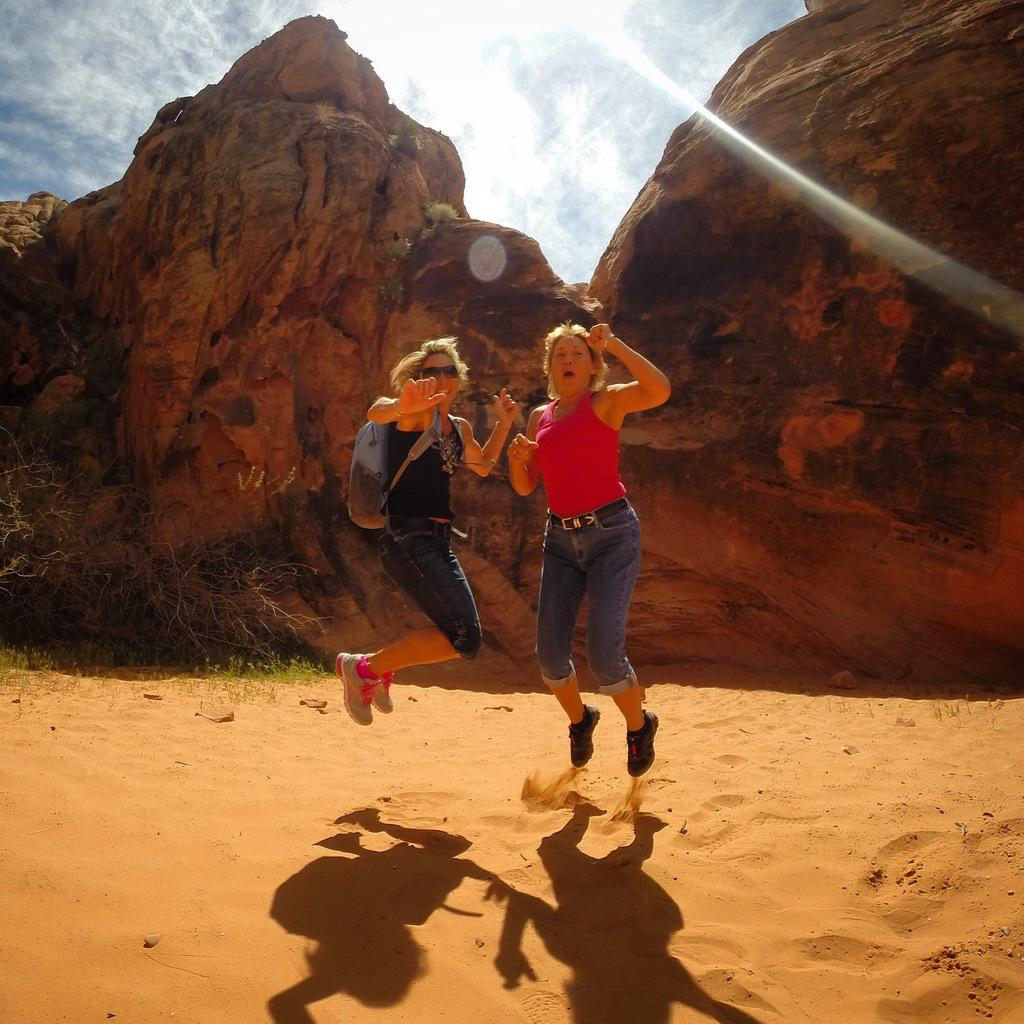Where was the image taken? The image was clicked outside. What can be seen at the top of the image? There is sky visible at the top of the image. Who are the people in the image? There are two women in the middle of the image. What are the women doing in the image? The women are jumping. What type of surface is visible at the bottom of the image? There is sand visible at the bottom of the image. How many deer can be seen grazing on the potato in the image? There are no deer or potatoes present in the image. 